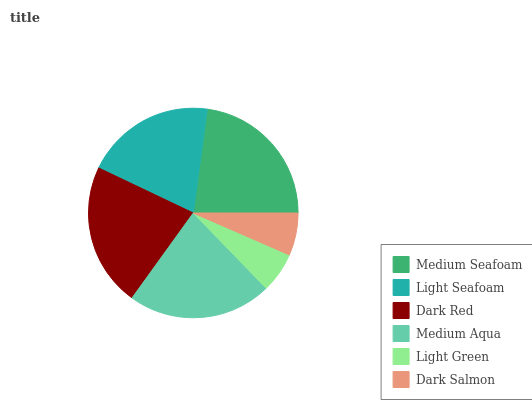Is Light Green the minimum?
Answer yes or no. Yes. Is Medium Seafoam the maximum?
Answer yes or no. Yes. Is Light Seafoam the minimum?
Answer yes or no. No. Is Light Seafoam the maximum?
Answer yes or no. No. Is Medium Seafoam greater than Light Seafoam?
Answer yes or no. Yes. Is Light Seafoam less than Medium Seafoam?
Answer yes or no. Yes. Is Light Seafoam greater than Medium Seafoam?
Answer yes or no. No. Is Medium Seafoam less than Light Seafoam?
Answer yes or no. No. Is Dark Red the high median?
Answer yes or no. Yes. Is Light Seafoam the low median?
Answer yes or no. Yes. Is Light Seafoam the high median?
Answer yes or no. No. Is Light Green the low median?
Answer yes or no. No. 